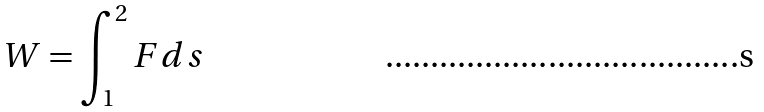Convert formula to latex. <formula><loc_0><loc_0><loc_500><loc_500>W = \int _ { 1 } ^ { 2 } F d s</formula> 